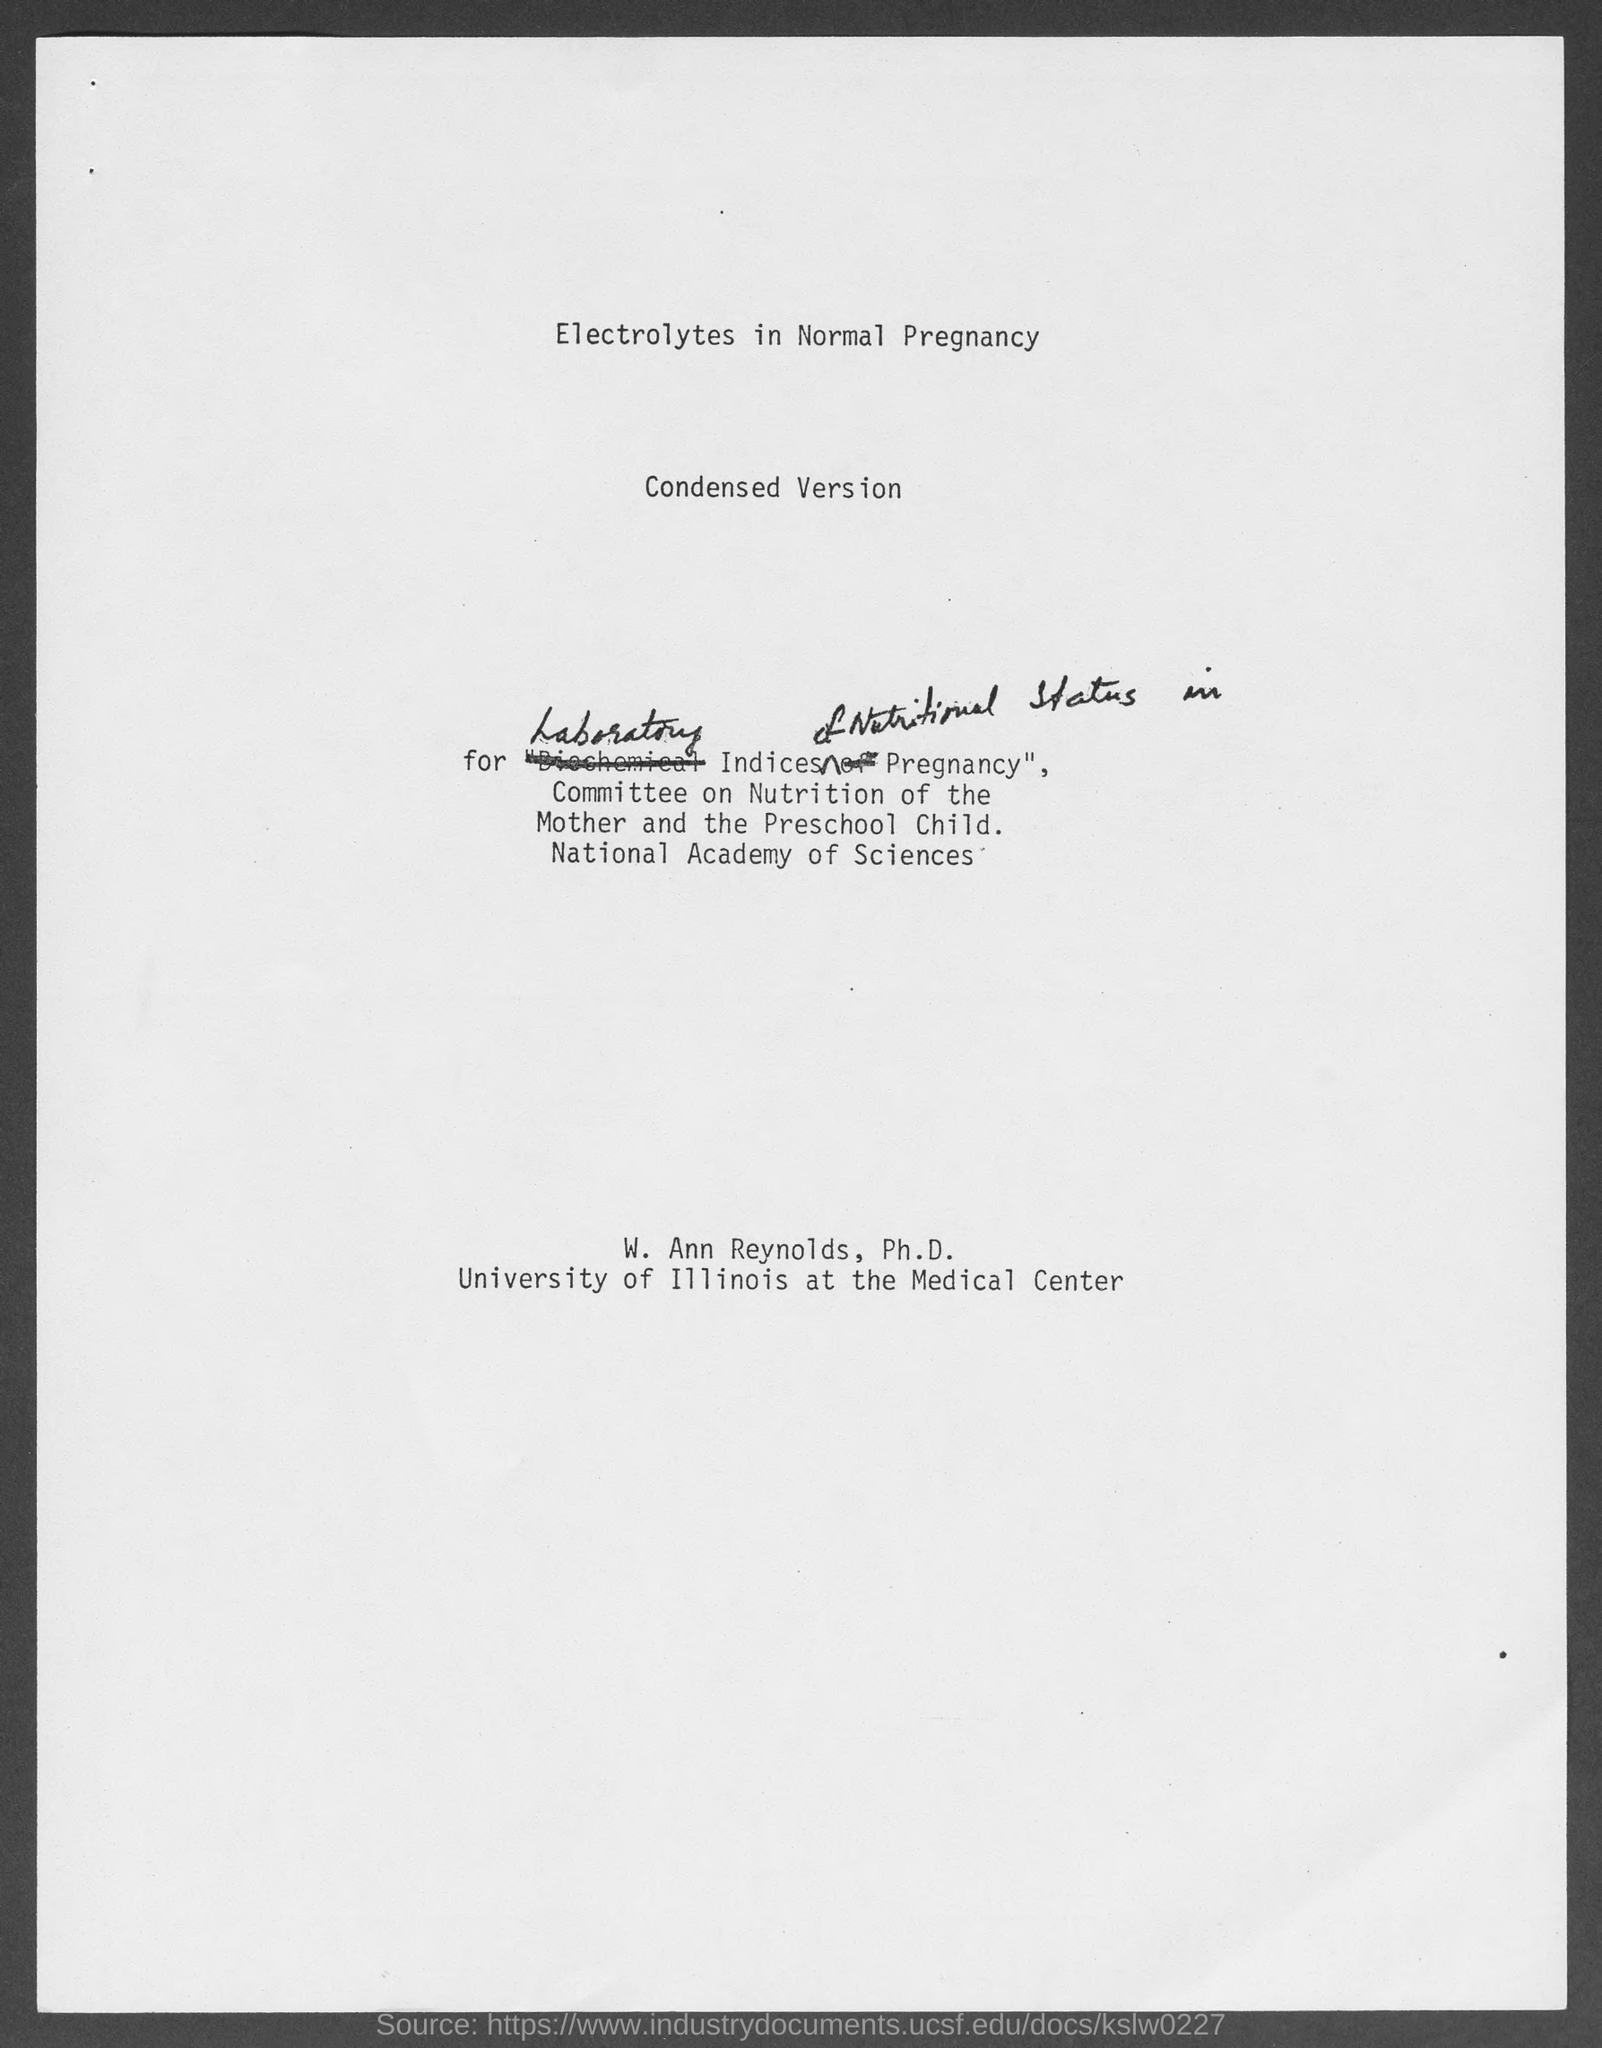What is the heading at top of the page ?
Offer a terse response. Electrolytes in Normal Pregnancy. 